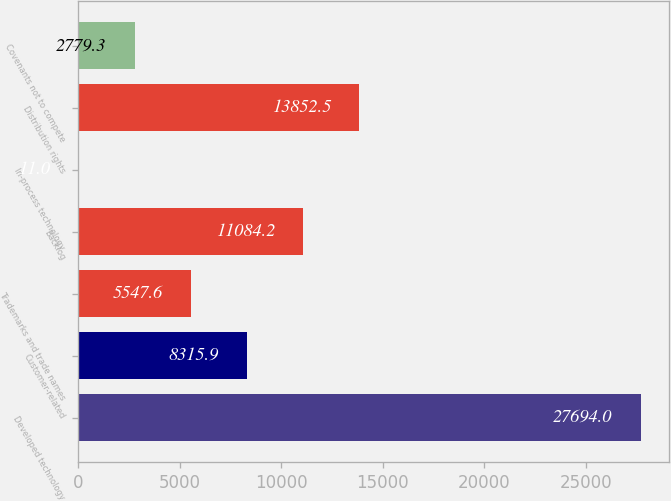Convert chart. <chart><loc_0><loc_0><loc_500><loc_500><bar_chart><fcel>Developed technology<fcel>Customer-related<fcel>Trademarks and trade names<fcel>Backlog<fcel>In-process technology<fcel>Distribution rights<fcel>Covenants not to compete<nl><fcel>27694<fcel>8315.9<fcel>5547.6<fcel>11084.2<fcel>11<fcel>13852.5<fcel>2779.3<nl></chart> 